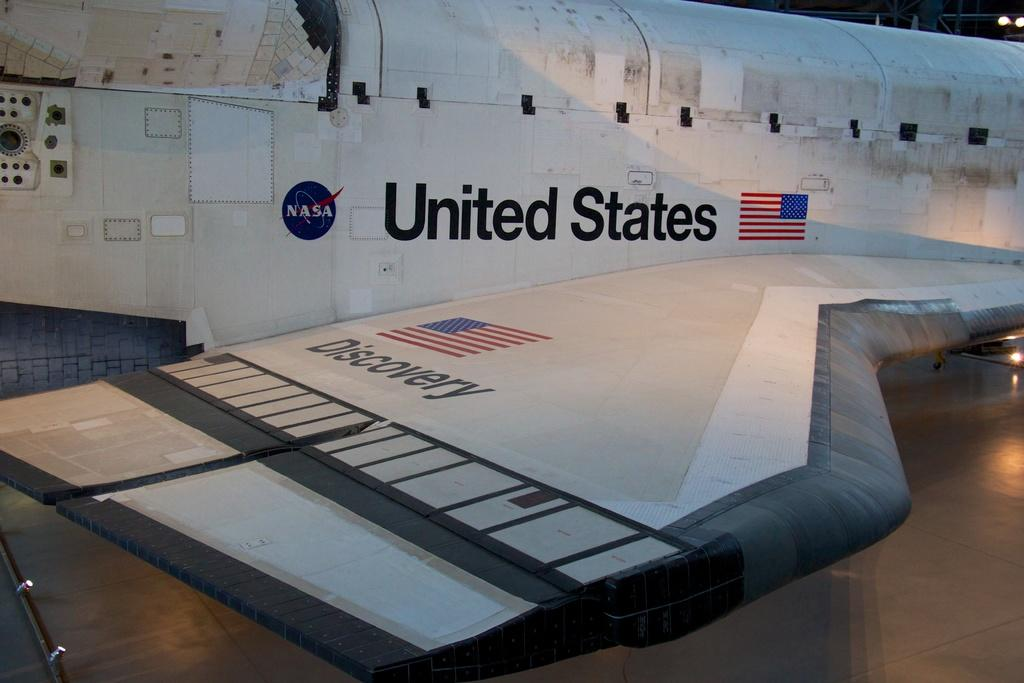<image>
Share a concise interpretation of the image provided. The space shuttle Discovery from NASA on Display 